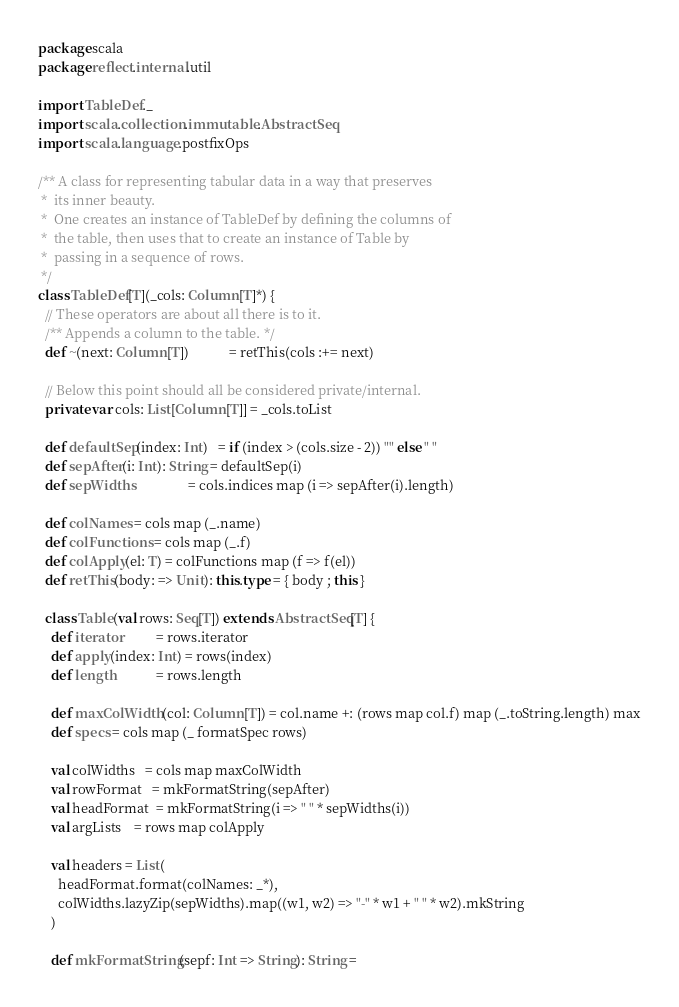<code> <loc_0><loc_0><loc_500><loc_500><_Scala_>package scala
package reflect.internal.util

import TableDef._
import scala.collection.immutable.AbstractSeq
import scala.language.postfixOps

/** A class for representing tabular data in a way that preserves
 *  its inner beauty.
 *  One creates an instance of TableDef by defining the columns of
 *  the table, then uses that to create an instance of Table by
 *  passing in a sequence of rows.
 */
class TableDef[T](_cols: Column[T]*) {
  // These operators are about all there is to it.
  /** Appends a column to the table. */
  def ~(next: Column[T])            = retThis(cols :+= next)

  // Below this point should all be considered private/internal.
  private var cols: List[Column[T]] = _cols.toList

  def defaultSep(index: Int)   = if (index > (cols.size - 2)) "" else " "
  def sepAfter(i: Int): String = defaultSep(i)
  def sepWidths                = cols.indices map (i => sepAfter(i).length)

  def colNames = cols map (_.name)
  def colFunctions = cols map (_.f)
  def colApply(el: T) = colFunctions map (f => f(el))
  def retThis(body: => Unit): this.type = { body ; this }

  class Table(val rows: Seq[T]) extends AbstractSeq[T] {
    def iterator          = rows.iterator
    def apply(index: Int) = rows(index)
    def length            = rows.length

    def maxColWidth(col: Column[T]) = col.name +: (rows map col.f) map (_.toString.length) max
    def specs = cols map (_ formatSpec rows)

    val colWidths   = cols map maxColWidth
    val rowFormat   = mkFormatString(sepAfter)
    val headFormat  = mkFormatString(i => " " * sepWidths(i))
    val argLists    = rows map colApply

    val headers = List(
      headFormat.format(colNames: _*),
      colWidths.lazyZip(sepWidths).map((w1, w2) => "-" * w1 + " " * w2).mkString
    )

    def mkFormatString(sepf: Int => String): String =</code> 